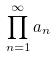<formula> <loc_0><loc_0><loc_500><loc_500>\prod _ { n = 1 } ^ { \infty } a _ { n }</formula> 